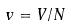<formula> <loc_0><loc_0><loc_500><loc_500>v = V / N</formula> 